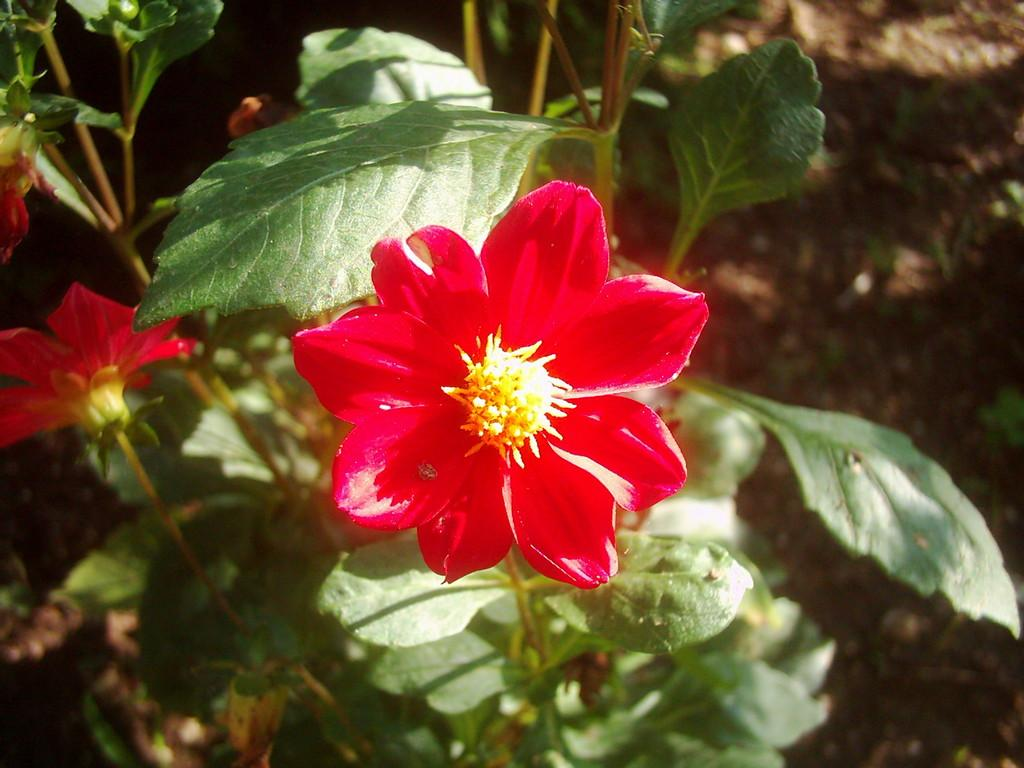What type of living organisms can be seen in the image? Plants and flowers are visible in the image. What color are the flowers in the image? The flowers in the image are red in color. Where is the robin perched in the image? There is no robin present in the image. What type of container is holding the flowers in the image? The provided facts do not mention a container for the flowers, so it cannot be determined from the image. 